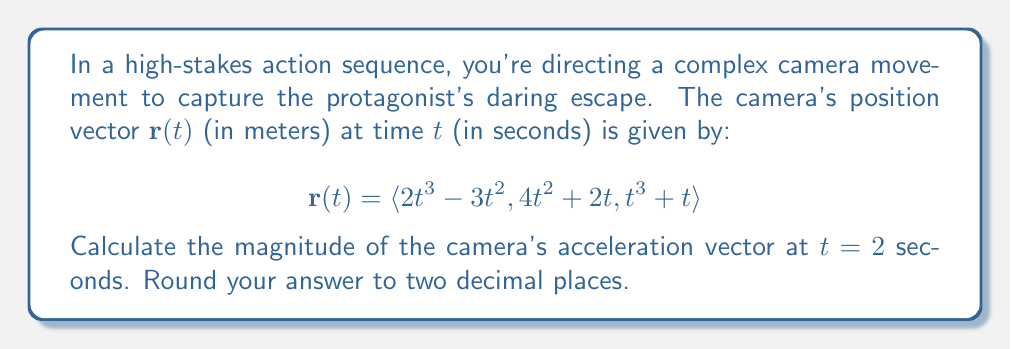Teach me how to tackle this problem. To solve this problem, we'll follow these steps:

1) First, we need to find the velocity vector $\mathbf{v}(t)$ by differentiating $\mathbf{r}(t)$ with respect to $t$:

   $$\mathbf{v}(t) = \frac{d}{dt}\mathbf{r}(t) = \langle 6t^2 - 6t, 8t + 2, 3t^2 + 1 \rangle$$

2) Then, we find the acceleration vector $\mathbf{a}(t)$ by differentiating $\mathbf{v}(t)$ with respect to $t$:

   $$\mathbf{a}(t) = \frac{d}{dt}\mathbf{v}(t) = \langle 12t - 6, 8, 6t \rangle$$

3) Now, we need to evaluate $\mathbf{a}(t)$ at $t = 2$:

   $$\mathbf{a}(2) = \langle 12(2) - 6, 8, 6(2) \rangle = \langle 18, 8, 12 \rangle$$

4) To find the magnitude of this acceleration vector, we use the formula:

   $$\|\mathbf{a}(2)\| = \sqrt{(18)^2 + (8)^2 + (12)^2}$$

5) Calculating:

   $$\|\mathbf{a}(2)\| = \sqrt{324 + 64 + 144} = \sqrt{532} \approx 23.07$$

Therefore, the magnitude of the camera's acceleration vector at $t = 2$ seconds is approximately 23.07 m/s².
Answer: 23.07 m/s² 